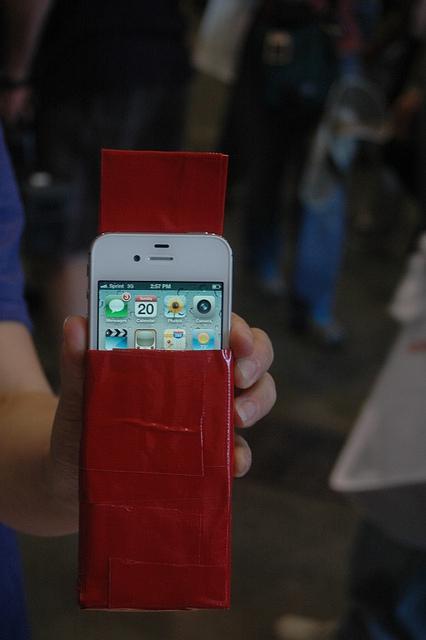How many cameras in the shot?
Give a very brief answer. 1. How many new messages are there?
Give a very brief answer. 1. How many phones are there?
Give a very brief answer. 1. How many people are there?
Give a very brief answer. 2. How many black horse ?
Give a very brief answer. 0. 